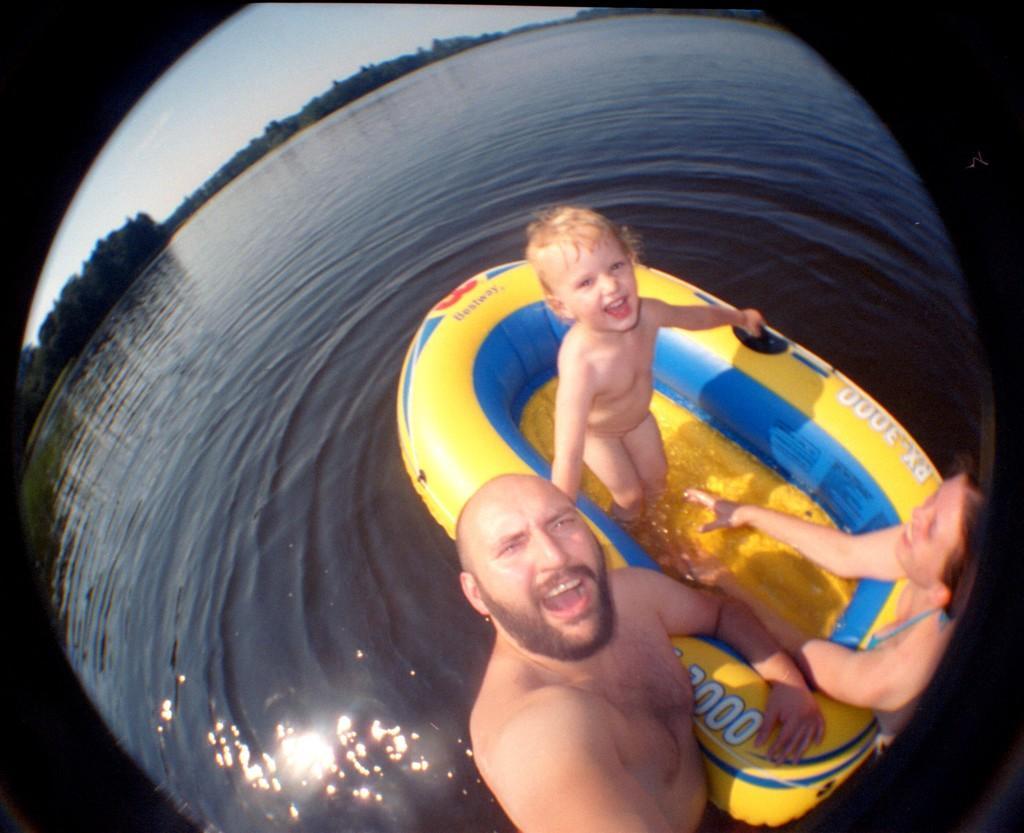Could you give a brief overview of what you see in this image? In the picture I can see a man and a woman is standing in the water. I can also see a child is standing on the rubber boat. In the background I can see trees and the sky. 